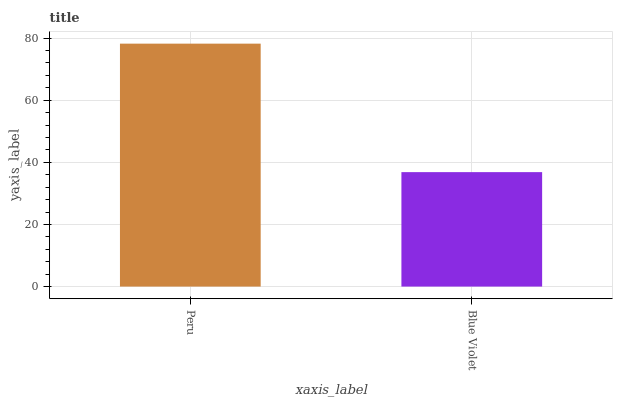Is Blue Violet the minimum?
Answer yes or no. Yes. Is Peru the maximum?
Answer yes or no. Yes. Is Blue Violet the maximum?
Answer yes or no. No. Is Peru greater than Blue Violet?
Answer yes or no. Yes. Is Blue Violet less than Peru?
Answer yes or no. Yes. Is Blue Violet greater than Peru?
Answer yes or no. No. Is Peru less than Blue Violet?
Answer yes or no. No. Is Peru the high median?
Answer yes or no. Yes. Is Blue Violet the low median?
Answer yes or no. Yes. Is Blue Violet the high median?
Answer yes or no. No. Is Peru the low median?
Answer yes or no. No. 